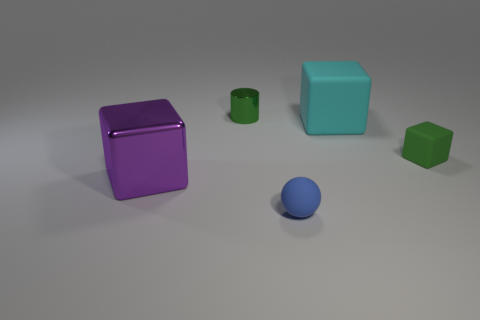Are there fewer matte cubes on the left side of the cyan block than objects right of the blue thing?
Your answer should be very brief. Yes. What shape is the thing that is in front of the green cylinder and left of the small blue rubber ball?
Provide a succinct answer. Cube. What number of big cyan matte things are the same shape as the blue rubber thing?
Provide a short and direct response. 0. What is the size of the block that is the same material as the cylinder?
Your answer should be very brief. Large. What number of purple blocks are the same size as the cyan rubber thing?
Give a very brief answer. 1. The matte object behind the green object that is to the right of the blue thing is what color?
Provide a succinct answer. Cyan. Is there a shiny cylinder of the same color as the tiny cube?
Give a very brief answer. Yes. There is a block that is the same size as the blue ball; what color is it?
Your answer should be very brief. Green. Do the green object in front of the tiny green metallic object and the cylinder have the same material?
Your response must be concise. No. There is a big object that is on the right side of the cube that is to the left of the tiny green shiny thing; are there any small green objects in front of it?
Your answer should be very brief. Yes. 